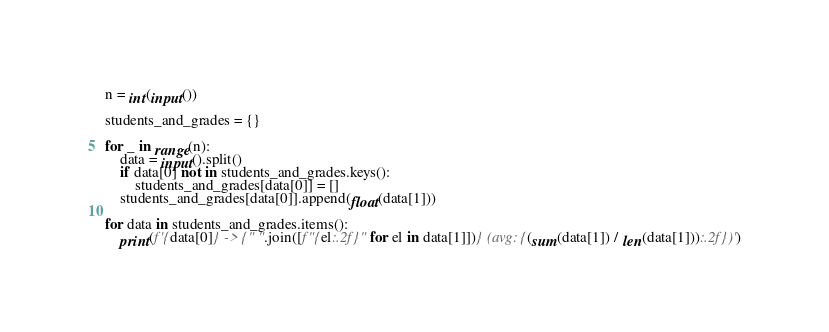<code> <loc_0><loc_0><loc_500><loc_500><_Python_>n = int(input())

students_and_grades = {}

for _ in range(n):
    data = input().split()
    if data[0] not in students_and_grades.keys():
        students_and_grades[data[0]] = []
    students_and_grades[data[0]].append(float(data[1]))

for data in students_and_grades.items():
    print(f'{data[0]} -> {" ".join([f"{el:.2f}" for el in data[1]])} (avg: {(sum(data[1]) / len(data[1])):.2f})')</code> 